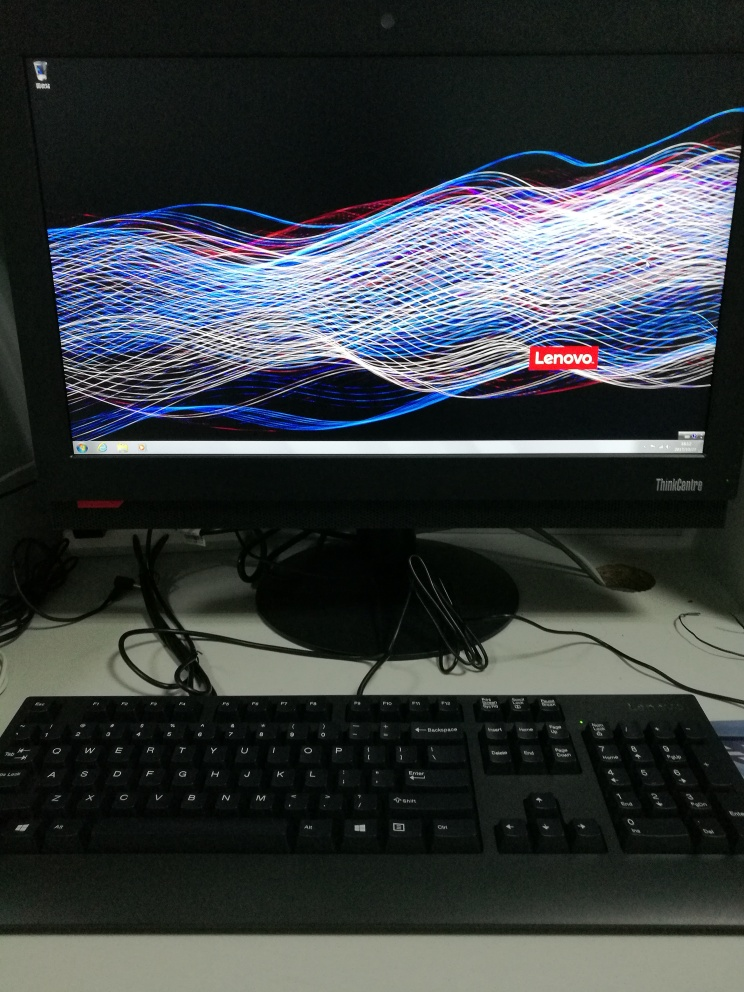Are the colors monotonous? Upon examining the image, it appears that the colors are not monotonous; rather, the display presents a dynamic range of colors intertwined in a complex wave pattern, predominantly featuring red, white, and blue hues against a black backdrop. 